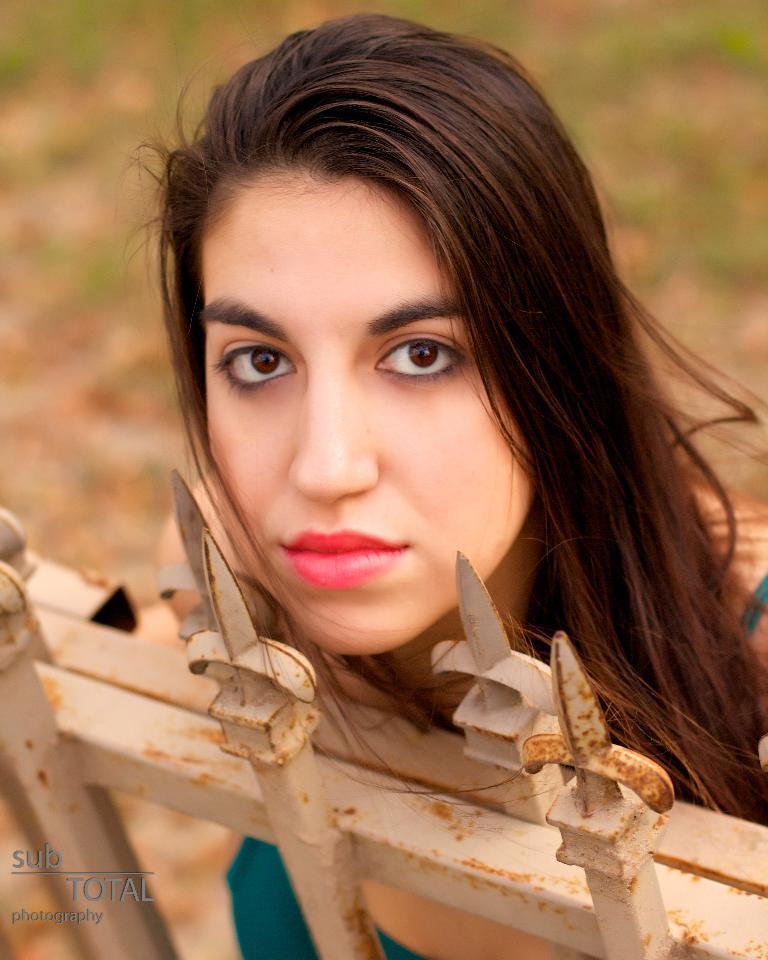Please provide a concise description of this image. This picture is clicked outside. In the foreground there is a metal object seems to be a metal gate and there is a woman seems to be standing on the ground. The background of the image is blur and we can see the small portion of the green grass. At the bottom left corner there is a text on the image. 